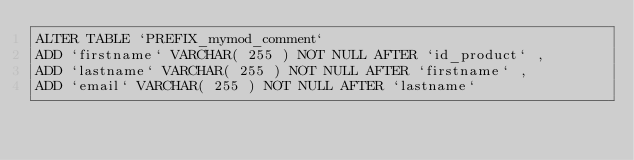Convert code to text. <code><loc_0><loc_0><loc_500><loc_500><_SQL_>ALTER TABLE `PREFIX_mymod_comment`
ADD `firstname` VARCHAR( 255 ) NOT NULL AFTER `id_product` ,
ADD `lastname` VARCHAR( 255 ) NOT NULL AFTER `firstname` ,
ADD `email` VARCHAR( 255 ) NOT NULL AFTER `lastname`</code> 